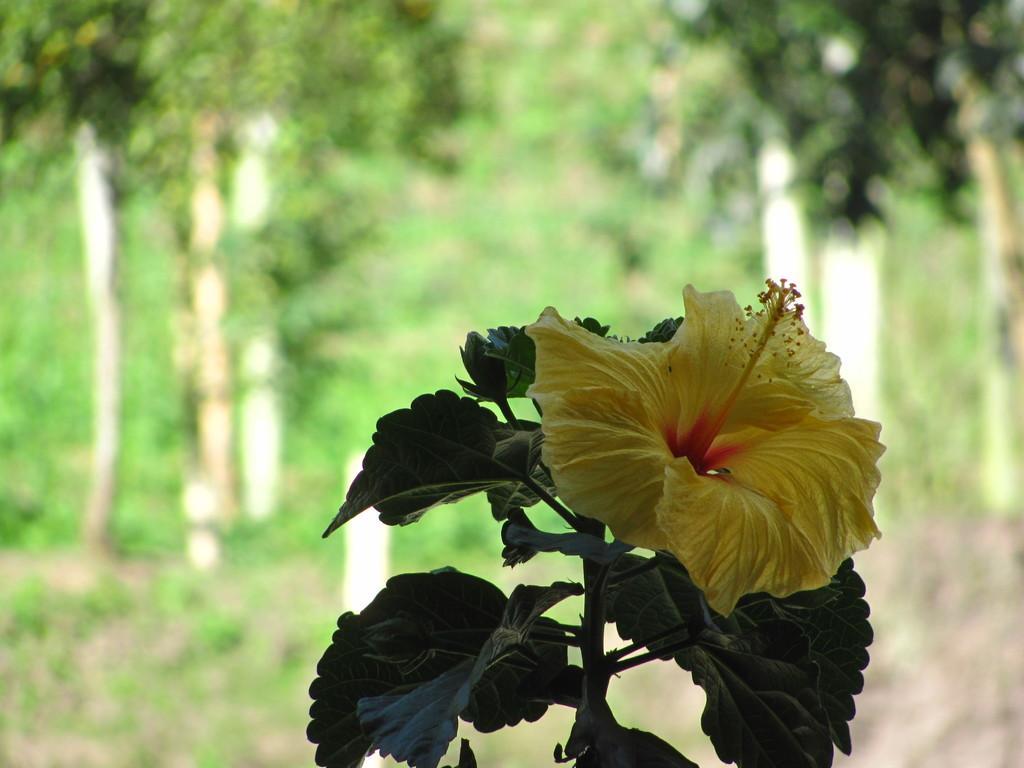Please provide a concise description of this image. In the image there is a hibiscus flower to a plant and the background of the plant is blur. 